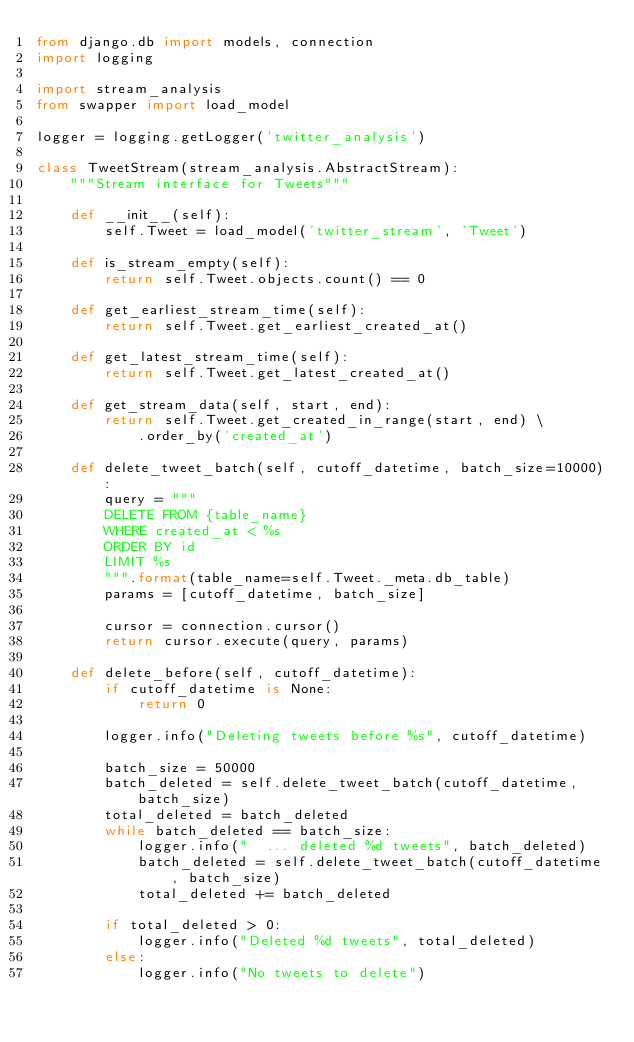<code> <loc_0><loc_0><loc_500><loc_500><_Python_>from django.db import models, connection
import logging

import stream_analysis
from swapper import load_model

logger = logging.getLogger('twitter_analysis')

class TweetStream(stream_analysis.AbstractStream):
    """Stream interface for Tweets"""

    def __init__(self):
        self.Tweet = load_model('twitter_stream', 'Tweet')

    def is_stream_empty(self):
        return self.Tweet.objects.count() == 0

    def get_earliest_stream_time(self):
        return self.Tweet.get_earliest_created_at()

    def get_latest_stream_time(self):
        return self.Tweet.get_latest_created_at()

    def get_stream_data(self, start, end):
        return self.Tweet.get_created_in_range(start, end) \
            .order_by('created_at')

    def delete_tweet_batch(self, cutoff_datetime, batch_size=10000):
        query = """
        DELETE FROM {table_name}
        WHERE created_at < %s
        ORDER BY id
        LIMIT %s
        """.format(table_name=self.Tweet._meta.db_table)
        params = [cutoff_datetime, batch_size]

        cursor = connection.cursor()
        return cursor.execute(query, params)

    def delete_before(self, cutoff_datetime):
        if cutoff_datetime is None:
            return 0

        logger.info("Deleting tweets before %s", cutoff_datetime)

        batch_size = 50000
        batch_deleted = self.delete_tweet_batch(cutoff_datetime, batch_size)
        total_deleted = batch_deleted
        while batch_deleted == batch_size:
            logger.info("  ... deleted %d tweets", batch_deleted)
            batch_deleted = self.delete_tweet_batch(cutoff_datetime, batch_size)
            total_deleted += batch_deleted

        if total_deleted > 0:
            logger.info("Deleted %d tweets", total_deleted)
        else:
            logger.info("No tweets to delete")
</code> 